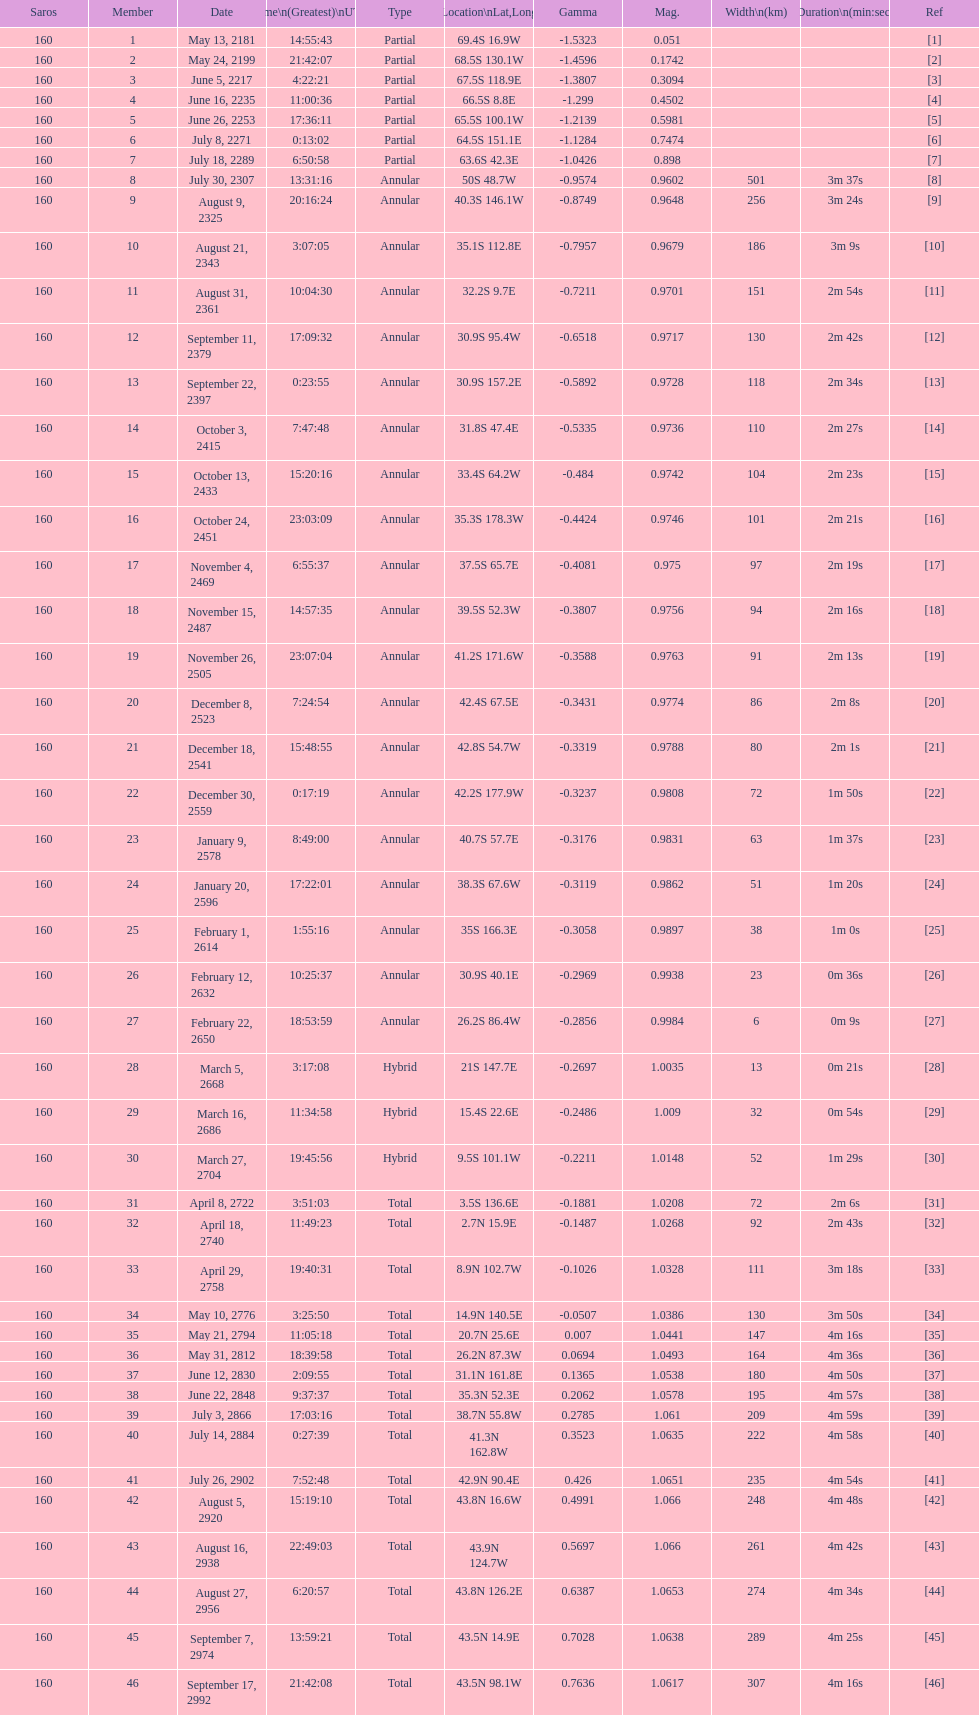Can you provide one example with the same latitude as the individual numbered 12? 13. 